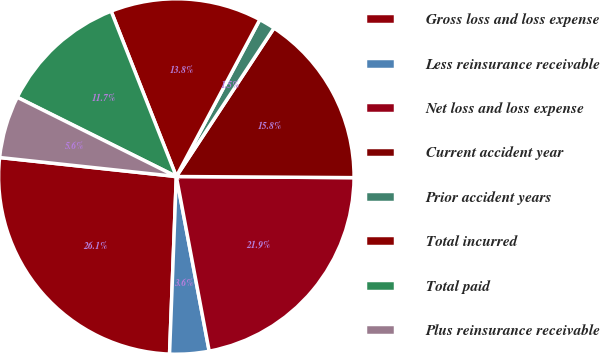Convert chart. <chart><loc_0><loc_0><loc_500><loc_500><pie_chart><fcel>Gross loss and loss expense<fcel>Less reinsurance receivable<fcel>Net loss and loss expense<fcel>Current accident year<fcel>Prior accident years<fcel>Total incurred<fcel>Total paid<fcel>Plus reinsurance receivable<nl><fcel>26.1%<fcel>3.57%<fcel>21.94%<fcel>15.84%<fcel>1.48%<fcel>13.76%<fcel>11.67%<fcel>5.65%<nl></chart> 